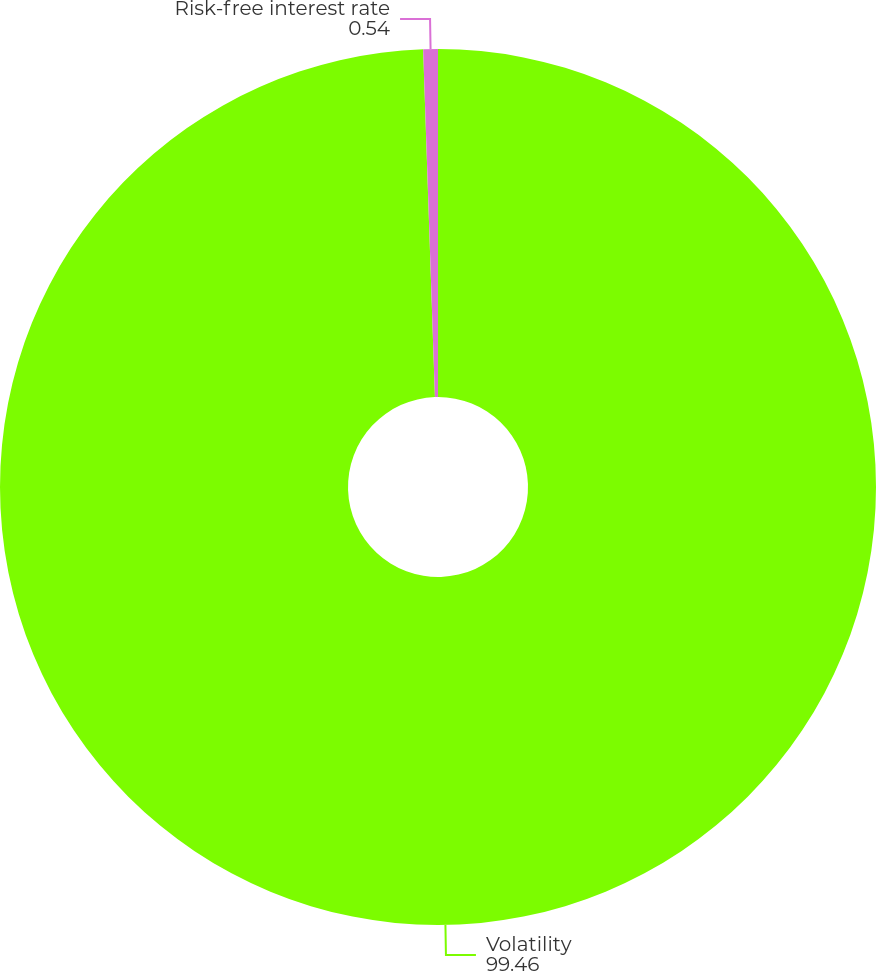Convert chart to OTSL. <chart><loc_0><loc_0><loc_500><loc_500><pie_chart><fcel>Volatility<fcel>Risk-free interest rate<nl><fcel>99.46%<fcel>0.54%<nl></chart> 